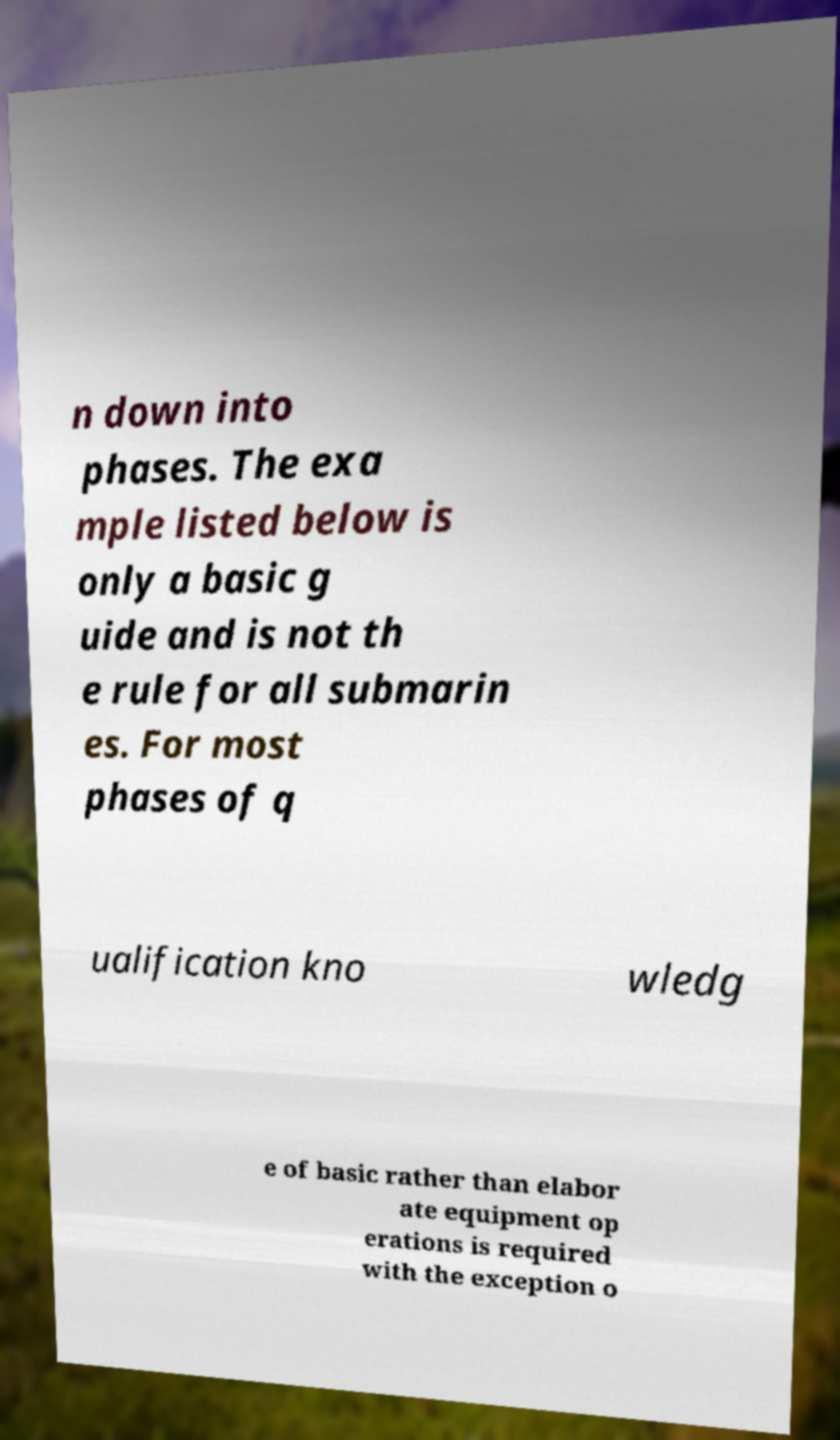Please read and relay the text visible in this image. What does it say? n down into phases. The exa mple listed below is only a basic g uide and is not th e rule for all submarin es. For most phases of q ualification kno wledg e of basic rather than elabor ate equipment op erations is required with the exception o 